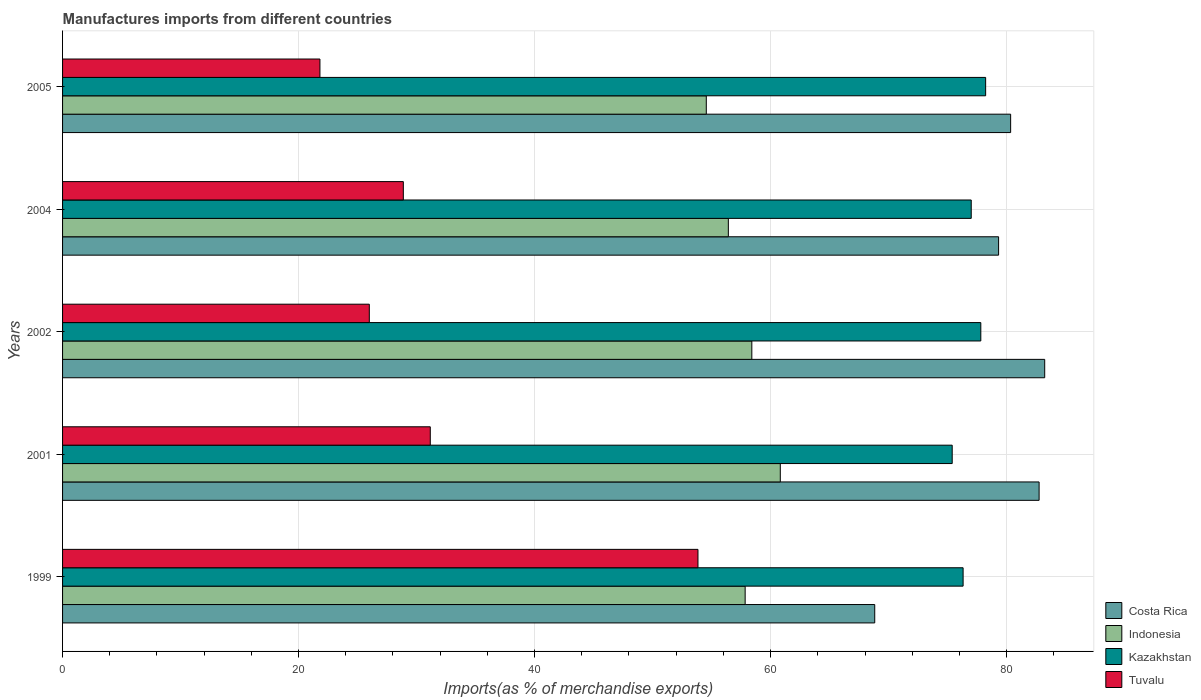How many different coloured bars are there?
Offer a terse response. 4. How many groups of bars are there?
Your answer should be very brief. 5. Are the number of bars per tick equal to the number of legend labels?
Your answer should be compact. Yes. How many bars are there on the 5th tick from the top?
Ensure brevity in your answer.  4. How many bars are there on the 1st tick from the bottom?
Offer a terse response. 4. In how many cases, is the number of bars for a given year not equal to the number of legend labels?
Provide a short and direct response. 0. What is the percentage of imports to different countries in Tuvalu in 1999?
Your answer should be very brief. 53.85. Across all years, what is the maximum percentage of imports to different countries in Tuvalu?
Ensure brevity in your answer.  53.85. Across all years, what is the minimum percentage of imports to different countries in Kazakhstan?
Provide a short and direct response. 75.39. In which year was the percentage of imports to different countries in Indonesia maximum?
Provide a succinct answer. 2001. In which year was the percentage of imports to different countries in Costa Rica minimum?
Your answer should be compact. 1999. What is the total percentage of imports to different countries in Costa Rica in the graph?
Your answer should be very brief. 394.47. What is the difference between the percentage of imports to different countries in Tuvalu in 1999 and that in 2002?
Provide a succinct answer. 27.85. What is the difference between the percentage of imports to different countries in Indonesia in 2005 and the percentage of imports to different countries in Tuvalu in 2002?
Give a very brief answer. 28.56. What is the average percentage of imports to different countries in Kazakhstan per year?
Provide a short and direct response. 76.95. In the year 1999, what is the difference between the percentage of imports to different countries in Costa Rica and percentage of imports to different countries in Tuvalu?
Offer a very short reply. 14.98. In how many years, is the percentage of imports to different countries in Indonesia greater than 32 %?
Provide a short and direct response. 5. What is the ratio of the percentage of imports to different countries in Tuvalu in 2004 to that in 2005?
Offer a very short reply. 1.32. Is the percentage of imports to different countries in Tuvalu in 2001 less than that in 2005?
Your answer should be very brief. No. Is the difference between the percentage of imports to different countries in Costa Rica in 2001 and 2004 greater than the difference between the percentage of imports to different countries in Tuvalu in 2001 and 2004?
Provide a succinct answer. Yes. What is the difference between the highest and the second highest percentage of imports to different countries in Tuvalu?
Keep it short and to the point. 22.68. What is the difference between the highest and the lowest percentage of imports to different countries in Costa Rica?
Give a very brief answer. 14.4. In how many years, is the percentage of imports to different countries in Tuvalu greater than the average percentage of imports to different countries in Tuvalu taken over all years?
Your answer should be very brief. 1. Is it the case that in every year, the sum of the percentage of imports to different countries in Indonesia and percentage of imports to different countries in Tuvalu is greater than the sum of percentage of imports to different countries in Costa Rica and percentage of imports to different countries in Kazakhstan?
Your answer should be compact. Yes. What does the 1st bar from the top in 2001 represents?
Offer a very short reply. Tuvalu. What does the 1st bar from the bottom in 2001 represents?
Offer a very short reply. Costa Rica. Are all the bars in the graph horizontal?
Provide a succinct answer. Yes. What is the difference between two consecutive major ticks on the X-axis?
Give a very brief answer. 20. What is the title of the graph?
Make the answer very short. Manufactures imports from different countries. What is the label or title of the X-axis?
Offer a terse response. Imports(as % of merchandise exports). What is the Imports(as % of merchandise exports) in Costa Rica in 1999?
Your response must be concise. 68.82. What is the Imports(as % of merchandise exports) of Indonesia in 1999?
Make the answer very short. 57.84. What is the Imports(as % of merchandise exports) in Kazakhstan in 1999?
Give a very brief answer. 76.31. What is the Imports(as % of merchandise exports) of Tuvalu in 1999?
Offer a very short reply. 53.85. What is the Imports(as % of merchandise exports) in Costa Rica in 2001?
Your answer should be compact. 82.75. What is the Imports(as % of merchandise exports) of Indonesia in 2001?
Provide a short and direct response. 60.82. What is the Imports(as % of merchandise exports) of Kazakhstan in 2001?
Keep it short and to the point. 75.39. What is the Imports(as % of merchandise exports) of Tuvalu in 2001?
Ensure brevity in your answer.  31.16. What is the Imports(as % of merchandise exports) in Costa Rica in 2002?
Your answer should be compact. 83.23. What is the Imports(as % of merchandise exports) in Indonesia in 2002?
Offer a terse response. 58.41. What is the Imports(as % of merchandise exports) in Kazakhstan in 2002?
Offer a very short reply. 77.81. What is the Imports(as % of merchandise exports) in Tuvalu in 2002?
Keep it short and to the point. 25.99. What is the Imports(as % of merchandise exports) in Costa Rica in 2004?
Offer a terse response. 79.32. What is the Imports(as % of merchandise exports) in Indonesia in 2004?
Make the answer very short. 56.42. What is the Imports(as % of merchandise exports) of Kazakhstan in 2004?
Your response must be concise. 77. What is the Imports(as % of merchandise exports) in Tuvalu in 2004?
Give a very brief answer. 28.88. What is the Imports(as % of merchandise exports) in Costa Rica in 2005?
Provide a short and direct response. 80.34. What is the Imports(as % of merchandise exports) in Indonesia in 2005?
Offer a very short reply. 54.55. What is the Imports(as % of merchandise exports) of Kazakhstan in 2005?
Give a very brief answer. 78.22. What is the Imports(as % of merchandise exports) in Tuvalu in 2005?
Provide a succinct answer. 21.81. Across all years, what is the maximum Imports(as % of merchandise exports) of Costa Rica?
Offer a very short reply. 83.23. Across all years, what is the maximum Imports(as % of merchandise exports) of Indonesia?
Provide a succinct answer. 60.82. Across all years, what is the maximum Imports(as % of merchandise exports) of Kazakhstan?
Your answer should be very brief. 78.22. Across all years, what is the maximum Imports(as % of merchandise exports) in Tuvalu?
Offer a terse response. 53.85. Across all years, what is the minimum Imports(as % of merchandise exports) of Costa Rica?
Offer a very short reply. 68.82. Across all years, what is the minimum Imports(as % of merchandise exports) of Indonesia?
Offer a terse response. 54.55. Across all years, what is the minimum Imports(as % of merchandise exports) of Kazakhstan?
Your answer should be compact. 75.39. Across all years, what is the minimum Imports(as % of merchandise exports) of Tuvalu?
Provide a short and direct response. 21.81. What is the total Imports(as % of merchandise exports) of Costa Rica in the graph?
Provide a short and direct response. 394.47. What is the total Imports(as % of merchandise exports) of Indonesia in the graph?
Offer a terse response. 288.05. What is the total Imports(as % of merchandise exports) in Kazakhstan in the graph?
Ensure brevity in your answer.  384.74. What is the total Imports(as % of merchandise exports) of Tuvalu in the graph?
Provide a succinct answer. 161.69. What is the difference between the Imports(as % of merchandise exports) in Costa Rica in 1999 and that in 2001?
Your answer should be compact. -13.93. What is the difference between the Imports(as % of merchandise exports) in Indonesia in 1999 and that in 2001?
Provide a short and direct response. -2.98. What is the difference between the Imports(as % of merchandise exports) of Kazakhstan in 1999 and that in 2001?
Offer a very short reply. 0.92. What is the difference between the Imports(as % of merchandise exports) of Tuvalu in 1999 and that in 2001?
Provide a succinct answer. 22.68. What is the difference between the Imports(as % of merchandise exports) in Costa Rica in 1999 and that in 2002?
Keep it short and to the point. -14.4. What is the difference between the Imports(as % of merchandise exports) of Indonesia in 1999 and that in 2002?
Keep it short and to the point. -0.57. What is the difference between the Imports(as % of merchandise exports) of Kazakhstan in 1999 and that in 2002?
Offer a very short reply. -1.5. What is the difference between the Imports(as % of merchandise exports) in Tuvalu in 1999 and that in 2002?
Your response must be concise. 27.85. What is the difference between the Imports(as % of merchandise exports) in Costa Rica in 1999 and that in 2004?
Keep it short and to the point. -10.5. What is the difference between the Imports(as % of merchandise exports) of Indonesia in 1999 and that in 2004?
Your answer should be compact. 1.42. What is the difference between the Imports(as % of merchandise exports) of Kazakhstan in 1999 and that in 2004?
Your answer should be very brief. -0.69. What is the difference between the Imports(as % of merchandise exports) in Tuvalu in 1999 and that in 2004?
Provide a short and direct response. 24.97. What is the difference between the Imports(as % of merchandise exports) of Costa Rica in 1999 and that in 2005?
Ensure brevity in your answer.  -11.52. What is the difference between the Imports(as % of merchandise exports) of Indonesia in 1999 and that in 2005?
Keep it short and to the point. 3.29. What is the difference between the Imports(as % of merchandise exports) of Kazakhstan in 1999 and that in 2005?
Make the answer very short. -1.91. What is the difference between the Imports(as % of merchandise exports) in Tuvalu in 1999 and that in 2005?
Make the answer very short. 32.03. What is the difference between the Imports(as % of merchandise exports) in Costa Rica in 2001 and that in 2002?
Your answer should be compact. -0.47. What is the difference between the Imports(as % of merchandise exports) of Indonesia in 2001 and that in 2002?
Keep it short and to the point. 2.41. What is the difference between the Imports(as % of merchandise exports) of Kazakhstan in 2001 and that in 2002?
Your response must be concise. -2.43. What is the difference between the Imports(as % of merchandise exports) of Tuvalu in 2001 and that in 2002?
Provide a short and direct response. 5.17. What is the difference between the Imports(as % of merchandise exports) of Costa Rica in 2001 and that in 2004?
Offer a very short reply. 3.43. What is the difference between the Imports(as % of merchandise exports) of Indonesia in 2001 and that in 2004?
Your response must be concise. 4.4. What is the difference between the Imports(as % of merchandise exports) in Kazakhstan in 2001 and that in 2004?
Provide a succinct answer. -1.61. What is the difference between the Imports(as % of merchandise exports) in Tuvalu in 2001 and that in 2004?
Provide a succinct answer. 2.28. What is the difference between the Imports(as % of merchandise exports) in Costa Rica in 2001 and that in 2005?
Ensure brevity in your answer.  2.41. What is the difference between the Imports(as % of merchandise exports) of Indonesia in 2001 and that in 2005?
Keep it short and to the point. 6.27. What is the difference between the Imports(as % of merchandise exports) of Kazakhstan in 2001 and that in 2005?
Make the answer very short. -2.83. What is the difference between the Imports(as % of merchandise exports) in Tuvalu in 2001 and that in 2005?
Keep it short and to the point. 9.35. What is the difference between the Imports(as % of merchandise exports) in Costa Rica in 2002 and that in 2004?
Provide a succinct answer. 3.91. What is the difference between the Imports(as % of merchandise exports) of Indonesia in 2002 and that in 2004?
Offer a very short reply. 1.99. What is the difference between the Imports(as % of merchandise exports) of Kazakhstan in 2002 and that in 2004?
Keep it short and to the point. 0.81. What is the difference between the Imports(as % of merchandise exports) of Tuvalu in 2002 and that in 2004?
Your answer should be compact. -2.88. What is the difference between the Imports(as % of merchandise exports) in Costa Rica in 2002 and that in 2005?
Your answer should be very brief. 2.89. What is the difference between the Imports(as % of merchandise exports) of Indonesia in 2002 and that in 2005?
Your answer should be compact. 3.86. What is the difference between the Imports(as % of merchandise exports) of Kazakhstan in 2002 and that in 2005?
Your answer should be compact. -0.41. What is the difference between the Imports(as % of merchandise exports) in Tuvalu in 2002 and that in 2005?
Offer a terse response. 4.18. What is the difference between the Imports(as % of merchandise exports) in Costa Rica in 2004 and that in 2005?
Make the answer very short. -1.02. What is the difference between the Imports(as % of merchandise exports) in Indonesia in 2004 and that in 2005?
Give a very brief answer. 1.87. What is the difference between the Imports(as % of merchandise exports) in Kazakhstan in 2004 and that in 2005?
Make the answer very short. -1.22. What is the difference between the Imports(as % of merchandise exports) in Tuvalu in 2004 and that in 2005?
Offer a very short reply. 7.07. What is the difference between the Imports(as % of merchandise exports) of Costa Rica in 1999 and the Imports(as % of merchandise exports) of Indonesia in 2001?
Give a very brief answer. 8. What is the difference between the Imports(as % of merchandise exports) of Costa Rica in 1999 and the Imports(as % of merchandise exports) of Kazakhstan in 2001?
Your response must be concise. -6.56. What is the difference between the Imports(as % of merchandise exports) in Costa Rica in 1999 and the Imports(as % of merchandise exports) in Tuvalu in 2001?
Ensure brevity in your answer.  37.66. What is the difference between the Imports(as % of merchandise exports) of Indonesia in 1999 and the Imports(as % of merchandise exports) of Kazakhstan in 2001?
Provide a short and direct response. -17.55. What is the difference between the Imports(as % of merchandise exports) in Indonesia in 1999 and the Imports(as % of merchandise exports) in Tuvalu in 2001?
Your answer should be very brief. 26.68. What is the difference between the Imports(as % of merchandise exports) in Kazakhstan in 1999 and the Imports(as % of merchandise exports) in Tuvalu in 2001?
Provide a short and direct response. 45.15. What is the difference between the Imports(as % of merchandise exports) in Costa Rica in 1999 and the Imports(as % of merchandise exports) in Indonesia in 2002?
Keep it short and to the point. 10.42. What is the difference between the Imports(as % of merchandise exports) of Costa Rica in 1999 and the Imports(as % of merchandise exports) of Kazakhstan in 2002?
Provide a short and direct response. -8.99. What is the difference between the Imports(as % of merchandise exports) of Costa Rica in 1999 and the Imports(as % of merchandise exports) of Tuvalu in 2002?
Provide a succinct answer. 42.83. What is the difference between the Imports(as % of merchandise exports) in Indonesia in 1999 and the Imports(as % of merchandise exports) in Kazakhstan in 2002?
Keep it short and to the point. -19.97. What is the difference between the Imports(as % of merchandise exports) of Indonesia in 1999 and the Imports(as % of merchandise exports) of Tuvalu in 2002?
Your answer should be very brief. 31.85. What is the difference between the Imports(as % of merchandise exports) in Kazakhstan in 1999 and the Imports(as % of merchandise exports) in Tuvalu in 2002?
Provide a short and direct response. 50.32. What is the difference between the Imports(as % of merchandise exports) of Costa Rica in 1999 and the Imports(as % of merchandise exports) of Indonesia in 2004?
Provide a succinct answer. 12.41. What is the difference between the Imports(as % of merchandise exports) of Costa Rica in 1999 and the Imports(as % of merchandise exports) of Kazakhstan in 2004?
Your answer should be very brief. -8.18. What is the difference between the Imports(as % of merchandise exports) of Costa Rica in 1999 and the Imports(as % of merchandise exports) of Tuvalu in 2004?
Keep it short and to the point. 39.95. What is the difference between the Imports(as % of merchandise exports) in Indonesia in 1999 and the Imports(as % of merchandise exports) in Kazakhstan in 2004?
Your answer should be very brief. -19.16. What is the difference between the Imports(as % of merchandise exports) in Indonesia in 1999 and the Imports(as % of merchandise exports) in Tuvalu in 2004?
Make the answer very short. 28.97. What is the difference between the Imports(as % of merchandise exports) of Kazakhstan in 1999 and the Imports(as % of merchandise exports) of Tuvalu in 2004?
Your answer should be very brief. 47.44. What is the difference between the Imports(as % of merchandise exports) in Costa Rica in 1999 and the Imports(as % of merchandise exports) in Indonesia in 2005?
Make the answer very short. 14.27. What is the difference between the Imports(as % of merchandise exports) of Costa Rica in 1999 and the Imports(as % of merchandise exports) of Kazakhstan in 2005?
Make the answer very short. -9.4. What is the difference between the Imports(as % of merchandise exports) in Costa Rica in 1999 and the Imports(as % of merchandise exports) in Tuvalu in 2005?
Ensure brevity in your answer.  47.01. What is the difference between the Imports(as % of merchandise exports) in Indonesia in 1999 and the Imports(as % of merchandise exports) in Kazakhstan in 2005?
Ensure brevity in your answer.  -20.38. What is the difference between the Imports(as % of merchandise exports) in Indonesia in 1999 and the Imports(as % of merchandise exports) in Tuvalu in 2005?
Make the answer very short. 36.03. What is the difference between the Imports(as % of merchandise exports) in Kazakhstan in 1999 and the Imports(as % of merchandise exports) in Tuvalu in 2005?
Make the answer very short. 54.5. What is the difference between the Imports(as % of merchandise exports) in Costa Rica in 2001 and the Imports(as % of merchandise exports) in Indonesia in 2002?
Offer a terse response. 24.35. What is the difference between the Imports(as % of merchandise exports) in Costa Rica in 2001 and the Imports(as % of merchandise exports) in Kazakhstan in 2002?
Make the answer very short. 4.94. What is the difference between the Imports(as % of merchandise exports) of Costa Rica in 2001 and the Imports(as % of merchandise exports) of Tuvalu in 2002?
Offer a terse response. 56.76. What is the difference between the Imports(as % of merchandise exports) in Indonesia in 2001 and the Imports(as % of merchandise exports) in Kazakhstan in 2002?
Make the answer very short. -16.99. What is the difference between the Imports(as % of merchandise exports) of Indonesia in 2001 and the Imports(as % of merchandise exports) of Tuvalu in 2002?
Give a very brief answer. 34.83. What is the difference between the Imports(as % of merchandise exports) in Kazakhstan in 2001 and the Imports(as % of merchandise exports) in Tuvalu in 2002?
Your answer should be very brief. 49.39. What is the difference between the Imports(as % of merchandise exports) in Costa Rica in 2001 and the Imports(as % of merchandise exports) in Indonesia in 2004?
Keep it short and to the point. 26.33. What is the difference between the Imports(as % of merchandise exports) of Costa Rica in 2001 and the Imports(as % of merchandise exports) of Kazakhstan in 2004?
Your response must be concise. 5.75. What is the difference between the Imports(as % of merchandise exports) in Costa Rica in 2001 and the Imports(as % of merchandise exports) in Tuvalu in 2004?
Ensure brevity in your answer.  53.88. What is the difference between the Imports(as % of merchandise exports) in Indonesia in 2001 and the Imports(as % of merchandise exports) in Kazakhstan in 2004?
Ensure brevity in your answer.  -16.18. What is the difference between the Imports(as % of merchandise exports) of Indonesia in 2001 and the Imports(as % of merchandise exports) of Tuvalu in 2004?
Keep it short and to the point. 31.95. What is the difference between the Imports(as % of merchandise exports) of Kazakhstan in 2001 and the Imports(as % of merchandise exports) of Tuvalu in 2004?
Give a very brief answer. 46.51. What is the difference between the Imports(as % of merchandise exports) of Costa Rica in 2001 and the Imports(as % of merchandise exports) of Indonesia in 2005?
Your answer should be very brief. 28.2. What is the difference between the Imports(as % of merchandise exports) in Costa Rica in 2001 and the Imports(as % of merchandise exports) in Kazakhstan in 2005?
Your answer should be compact. 4.53. What is the difference between the Imports(as % of merchandise exports) of Costa Rica in 2001 and the Imports(as % of merchandise exports) of Tuvalu in 2005?
Provide a short and direct response. 60.94. What is the difference between the Imports(as % of merchandise exports) of Indonesia in 2001 and the Imports(as % of merchandise exports) of Kazakhstan in 2005?
Ensure brevity in your answer.  -17.4. What is the difference between the Imports(as % of merchandise exports) in Indonesia in 2001 and the Imports(as % of merchandise exports) in Tuvalu in 2005?
Offer a terse response. 39.01. What is the difference between the Imports(as % of merchandise exports) in Kazakhstan in 2001 and the Imports(as % of merchandise exports) in Tuvalu in 2005?
Make the answer very short. 53.58. What is the difference between the Imports(as % of merchandise exports) in Costa Rica in 2002 and the Imports(as % of merchandise exports) in Indonesia in 2004?
Provide a short and direct response. 26.81. What is the difference between the Imports(as % of merchandise exports) in Costa Rica in 2002 and the Imports(as % of merchandise exports) in Kazakhstan in 2004?
Provide a succinct answer. 6.23. What is the difference between the Imports(as % of merchandise exports) in Costa Rica in 2002 and the Imports(as % of merchandise exports) in Tuvalu in 2004?
Provide a succinct answer. 54.35. What is the difference between the Imports(as % of merchandise exports) in Indonesia in 2002 and the Imports(as % of merchandise exports) in Kazakhstan in 2004?
Your response must be concise. -18.59. What is the difference between the Imports(as % of merchandise exports) of Indonesia in 2002 and the Imports(as % of merchandise exports) of Tuvalu in 2004?
Provide a short and direct response. 29.53. What is the difference between the Imports(as % of merchandise exports) of Kazakhstan in 2002 and the Imports(as % of merchandise exports) of Tuvalu in 2004?
Make the answer very short. 48.94. What is the difference between the Imports(as % of merchandise exports) of Costa Rica in 2002 and the Imports(as % of merchandise exports) of Indonesia in 2005?
Make the answer very short. 28.68. What is the difference between the Imports(as % of merchandise exports) of Costa Rica in 2002 and the Imports(as % of merchandise exports) of Kazakhstan in 2005?
Your answer should be compact. 5. What is the difference between the Imports(as % of merchandise exports) in Costa Rica in 2002 and the Imports(as % of merchandise exports) in Tuvalu in 2005?
Make the answer very short. 61.42. What is the difference between the Imports(as % of merchandise exports) in Indonesia in 2002 and the Imports(as % of merchandise exports) in Kazakhstan in 2005?
Keep it short and to the point. -19.81. What is the difference between the Imports(as % of merchandise exports) of Indonesia in 2002 and the Imports(as % of merchandise exports) of Tuvalu in 2005?
Your response must be concise. 36.6. What is the difference between the Imports(as % of merchandise exports) of Kazakhstan in 2002 and the Imports(as % of merchandise exports) of Tuvalu in 2005?
Your response must be concise. 56. What is the difference between the Imports(as % of merchandise exports) in Costa Rica in 2004 and the Imports(as % of merchandise exports) in Indonesia in 2005?
Keep it short and to the point. 24.77. What is the difference between the Imports(as % of merchandise exports) of Costa Rica in 2004 and the Imports(as % of merchandise exports) of Kazakhstan in 2005?
Your response must be concise. 1.1. What is the difference between the Imports(as % of merchandise exports) of Costa Rica in 2004 and the Imports(as % of merchandise exports) of Tuvalu in 2005?
Keep it short and to the point. 57.51. What is the difference between the Imports(as % of merchandise exports) in Indonesia in 2004 and the Imports(as % of merchandise exports) in Kazakhstan in 2005?
Your answer should be compact. -21.8. What is the difference between the Imports(as % of merchandise exports) in Indonesia in 2004 and the Imports(as % of merchandise exports) in Tuvalu in 2005?
Offer a terse response. 34.61. What is the difference between the Imports(as % of merchandise exports) of Kazakhstan in 2004 and the Imports(as % of merchandise exports) of Tuvalu in 2005?
Give a very brief answer. 55.19. What is the average Imports(as % of merchandise exports) in Costa Rica per year?
Keep it short and to the point. 78.89. What is the average Imports(as % of merchandise exports) of Indonesia per year?
Make the answer very short. 57.61. What is the average Imports(as % of merchandise exports) in Kazakhstan per year?
Provide a succinct answer. 76.95. What is the average Imports(as % of merchandise exports) in Tuvalu per year?
Your response must be concise. 32.34. In the year 1999, what is the difference between the Imports(as % of merchandise exports) of Costa Rica and Imports(as % of merchandise exports) of Indonesia?
Ensure brevity in your answer.  10.98. In the year 1999, what is the difference between the Imports(as % of merchandise exports) of Costa Rica and Imports(as % of merchandise exports) of Kazakhstan?
Your response must be concise. -7.49. In the year 1999, what is the difference between the Imports(as % of merchandise exports) of Costa Rica and Imports(as % of merchandise exports) of Tuvalu?
Provide a short and direct response. 14.98. In the year 1999, what is the difference between the Imports(as % of merchandise exports) in Indonesia and Imports(as % of merchandise exports) in Kazakhstan?
Your response must be concise. -18.47. In the year 1999, what is the difference between the Imports(as % of merchandise exports) of Indonesia and Imports(as % of merchandise exports) of Tuvalu?
Your answer should be very brief. 4. In the year 1999, what is the difference between the Imports(as % of merchandise exports) in Kazakhstan and Imports(as % of merchandise exports) in Tuvalu?
Ensure brevity in your answer.  22.47. In the year 2001, what is the difference between the Imports(as % of merchandise exports) in Costa Rica and Imports(as % of merchandise exports) in Indonesia?
Offer a terse response. 21.93. In the year 2001, what is the difference between the Imports(as % of merchandise exports) of Costa Rica and Imports(as % of merchandise exports) of Kazakhstan?
Offer a very short reply. 7.37. In the year 2001, what is the difference between the Imports(as % of merchandise exports) in Costa Rica and Imports(as % of merchandise exports) in Tuvalu?
Provide a succinct answer. 51.59. In the year 2001, what is the difference between the Imports(as % of merchandise exports) of Indonesia and Imports(as % of merchandise exports) of Kazakhstan?
Make the answer very short. -14.57. In the year 2001, what is the difference between the Imports(as % of merchandise exports) in Indonesia and Imports(as % of merchandise exports) in Tuvalu?
Provide a succinct answer. 29.66. In the year 2001, what is the difference between the Imports(as % of merchandise exports) in Kazakhstan and Imports(as % of merchandise exports) in Tuvalu?
Make the answer very short. 44.23. In the year 2002, what is the difference between the Imports(as % of merchandise exports) of Costa Rica and Imports(as % of merchandise exports) of Indonesia?
Your answer should be compact. 24.82. In the year 2002, what is the difference between the Imports(as % of merchandise exports) in Costa Rica and Imports(as % of merchandise exports) in Kazakhstan?
Give a very brief answer. 5.41. In the year 2002, what is the difference between the Imports(as % of merchandise exports) of Costa Rica and Imports(as % of merchandise exports) of Tuvalu?
Ensure brevity in your answer.  57.23. In the year 2002, what is the difference between the Imports(as % of merchandise exports) of Indonesia and Imports(as % of merchandise exports) of Kazakhstan?
Provide a short and direct response. -19.41. In the year 2002, what is the difference between the Imports(as % of merchandise exports) in Indonesia and Imports(as % of merchandise exports) in Tuvalu?
Provide a succinct answer. 32.41. In the year 2002, what is the difference between the Imports(as % of merchandise exports) in Kazakhstan and Imports(as % of merchandise exports) in Tuvalu?
Make the answer very short. 51.82. In the year 2004, what is the difference between the Imports(as % of merchandise exports) in Costa Rica and Imports(as % of merchandise exports) in Indonesia?
Give a very brief answer. 22.9. In the year 2004, what is the difference between the Imports(as % of merchandise exports) of Costa Rica and Imports(as % of merchandise exports) of Kazakhstan?
Ensure brevity in your answer.  2.32. In the year 2004, what is the difference between the Imports(as % of merchandise exports) in Costa Rica and Imports(as % of merchandise exports) in Tuvalu?
Your answer should be very brief. 50.44. In the year 2004, what is the difference between the Imports(as % of merchandise exports) of Indonesia and Imports(as % of merchandise exports) of Kazakhstan?
Your answer should be very brief. -20.58. In the year 2004, what is the difference between the Imports(as % of merchandise exports) of Indonesia and Imports(as % of merchandise exports) of Tuvalu?
Provide a short and direct response. 27.54. In the year 2004, what is the difference between the Imports(as % of merchandise exports) of Kazakhstan and Imports(as % of merchandise exports) of Tuvalu?
Offer a very short reply. 48.13. In the year 2005, what is the difference between the Imports(as % of merchandise exports) in Costa Rica and Imports(as % of merchandise exports) in Indonesia?
Your answer should be compact. 25.79. In the year 2005, what is the difference between the Imports(as % of merchandise exports) in Costa Rica and Imports(as % of merchandise exports) in Kazakhstan?
Ensure brevity in your answer.  2.12. In the year 2005, what is the difference between the Imports(as % of merchandise exports) of Costa Rica and Imports(as % of merchandise exports) of Tuvalu?
Your answer should be compact. 58.53. In the year 2005, what is the difference between the Imports(as % of merchandise exports) in Indonesia and Imports(as % of merchandise exports) in Kazakhstan?
Provide a short and direct response. -23.67. In the year 2005, what is the difference between the Imports(as % of merchandise exports) of Indonesia and Imports(as % of merchandise exports) of Tuvalu?
Keep it short and to the point. 32.74. In the year 2005, what is the difference between the Imports(as % of merchandise exports) in Kazakhstan and Imports(as % of merchandise exports) in Tuvalu?
Your answer should be compact. 56.41. What is the ratio of the Imports(as % of merchandise exports) in Costa Rica in 1999 to that in 2001?
Offer a terse response. 0.83. What is the ratio of the Imports(as % of merchandise exports) of Indonesia in 1999 to that in 2001?
Ensure brevity in your answer.  0.95. What is the ratio of the Imports(as % of merchandise exports) in Kazakhstan in 1999 to that in 2001?
Ensure brevity in your answer.  1.01. What is the ratio of the Imports(as % of merchandise exports) in Tuvalu in 1999 to that in 2001?
Provide a short and direct response. 1.73. What is the ratio of the Imports(as % of merchandise exports) of Costa Rica in 1999 to that in 2002?
Provide a succinct answer. 0.83. What is the ratio of the Imports(as % of merchandise exports) in Indonesia in 1999 to that in 2002?
Give a very brief answer. 0.99. What is the ratio of the Imports(as % of merchandise exports) of Kazakhstan in 1999 to that in 2002?
Your answer should be compact. 0.98. What is the ratio of the Imports(as % of merchandise exports) in Tuvalu in 1999 to that in 2002?
Your answer should be compact. 2.07. What is the ratio of the Imports(as % of merchandise exports) of Costa Rica in 1999 to that in 2004?
Make the answer very short. 0.87. What is the ratio of the Imports(as % of merchandise exports) in Indonesia in 1999 to that in 2004?
Keep it short and to the point. 1.03. What is the ratio of the Imports(as % of merchandise exports) of Kazakhstan in 1999 to that in 2004?
Your answer should be very brief. 0.99. What is the ratio of the Imports(as % of merchandise exports) in Tuvalu in 1999 to that in 2004?
Provide a succinct answer. 1.86. What is the ratio of the Imports(as % of merchandise exports) in Costa Rica in 1999 to that in 2005?
Keep it short and to the point. 0.86. What is the ratio of the Imports(as % of merchandise exports) of Indonesia in 1999 to that in 2005?
Provide a short and direct response. 1.06. What is the ratio of the Imports(as % of merchandise exports) of Kazakhstan in 1999 to that in 2005?
Provide a short and direct response. 0.98. What is the ratio of the Imports(as % of merchandise exports) of Tuvalu in 1999 to that in 2005?
Give a very brief answer. 2.47. What is the ratio of the Imports(as % of merchandise exports) of Indonesia in 2001 to that in 2002?
Your answer should be very brief. 1.04. What is the ratio of the Imports(as % of merchandise exports) of Kazakhstan in 2001 to that in 2002?
Your answer should be compact. 0.97. What is the ratio of the Imports(as % of merchandise exports) in Tuvalu in 2001 to that in 2002?
Provide a succinct answer. 1.2. What is the ratio of the Imports(as % of merchandise exports) in Costa Rica in 2001 to that in 2004?
Offer a very short reply. 1.04. What is the ratio of the Imports(as % of merchandise exports) in Indonesia in 2001 to that in 2004?
Make the answer very short. 1.08. What is the ratio of the Imports(as % of merchandise exports) in Kazakhstan in 2001 to that in 2004?
Ensure brevity in your answer.  0.98. What is the ratio of the Imports(as % of merchandise exports) in Tuvalu in 2001 to that in 2004?
Offer a terse response. 1.08. What is the ratio of the Imports(as % of merchandise exports) of Indonesia in 2001 to that in 2005?
Give a very brief answer. 1.11. What is the ratio of the Imports(as % of merchandise exports) in Kazakhstan in 2001 to that in 2005?
Provide a short and direct response. 0.96. What is the ratio of the Imports(as % of merchandise exports) in Tuvalu in 2001 to that in 2005?
Your answer should be compact. 1.43. What is the ratio of the Imports(as % of merchandise exports) in Costa Rica in 2002 to that in 2004?
Keep it short and to the point. 1.05. What is the ratio of the Imports(as % of merchandise exports) in Indonesia in 2002 to that in 2004?
Your answer should be compact. 1.04. What is the ratio of the Imports(as % of merchandise exports) in Kazakhstan in 2002 to that in 2004?
Your response must be concise. 1.01. What is the ratio of the Imports(as % of merchandise exports) in Tuvalu in 2002 to that in 2004?
Offer a very short reply. 0.9. What is the ratio of the Imports(as % of merchandise exports) in Costa Rica in 2002 to that in 2005?
Give a very brief answer. 1.04. What is the ratio of the Imports(as % of merchandise exports) of Indonesia in 2002 to that in 2005?
Make the answer very short. 1.07. What is the ratio of the Imports(as % of merchandise exports) of Kazakhstan in 2002 to that in 2005?
Keep it short and to the point. 0.99. What is the ratio of the Imports(as % of merchandise exports) in Tuvalu in 2002 to that in 2005?
Give a very brief answer. 1.19. What is the ratio of the Imports(as % of merchandise exports) in Costa Rica in 2004 to that in 2005?
Provide a short and direct response. 0.99. What is the ratio of the Imports(as % of merchandise exports) of Indonesia in 2004 to that in 2005?
Keep it short and to the point. 1.03. What is the ratio of the Imports(as % of merchandise exports) of Kazakhstan in 2004 to that in 2005?
Offer a terse response. 0.98. What is the ratio of the Imports(as % of merchandise exports) in Tuvalu in 2004 to that in 2005?
Make the answer very short. 1.32. What is the difference between the highest and the second highest Imports(as % of merchandise exports) of Costa Rica?
Your answer should be very brief. 0.47. What is the difference between the highest and the second highest Imports(as % of merchandise exports) in Indonesia?
Your answer should be very brief. 2.41. What is the difference between the highest and the second highest Imports(as % of merchandise exports) of Kazakhstan?
Ensure brevity in your answer.  0.41. What is the difference between the highest and the second highest Imports(as % of merchandise exports) of Tuvalu?
Make the answer very short. 22.68. What is the difference between the highest and the lowest Imports(as % of merchandise exports) in Costa Rica?
Provide a short and direct response. 14.4. What is the difference between the highest and the lowest Imports(as % of merchandise exports) of Indonesia?
Provide a short and direct response. 6.27. What is the difference between the highest and the lowest Imports(as % of merchandise exports) in Kazakhstan?
Offer a very short reply. 2.83. What is the difference between the highest and the lowest Imports(as % of merchandise exports) in Tuvalu?
Offer a terse response. 32.03. 